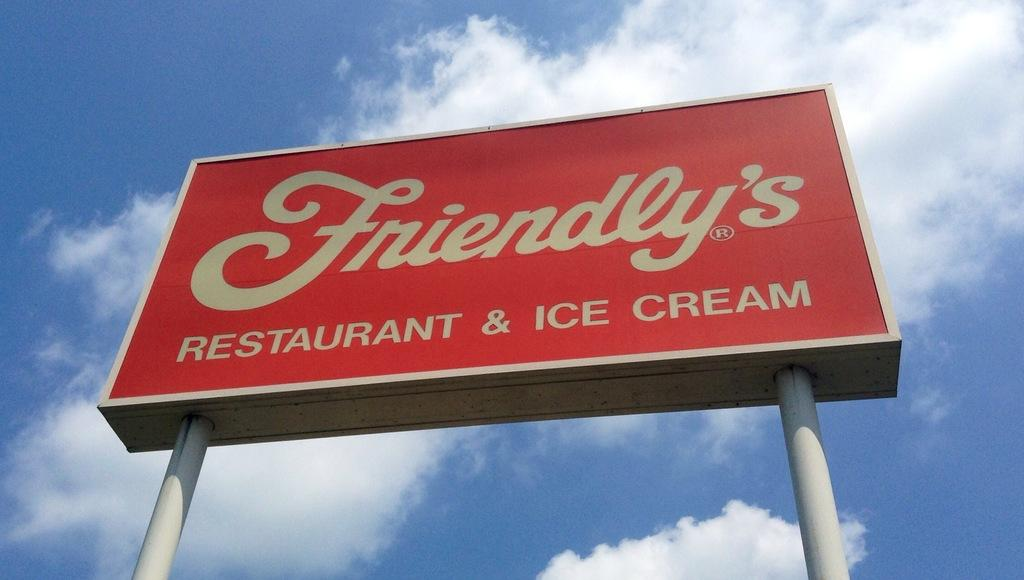<image>
Describe the image concisely. A red billboard sign for the restaurant Friendly's 